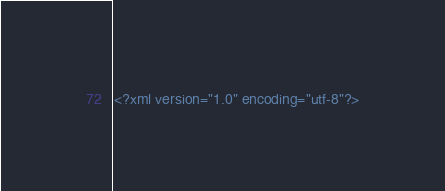<code> <loc_0><loc_0><loc_500><loc_500><_XML_><?xml version="1.0" encoding="utf-8"?></code> 